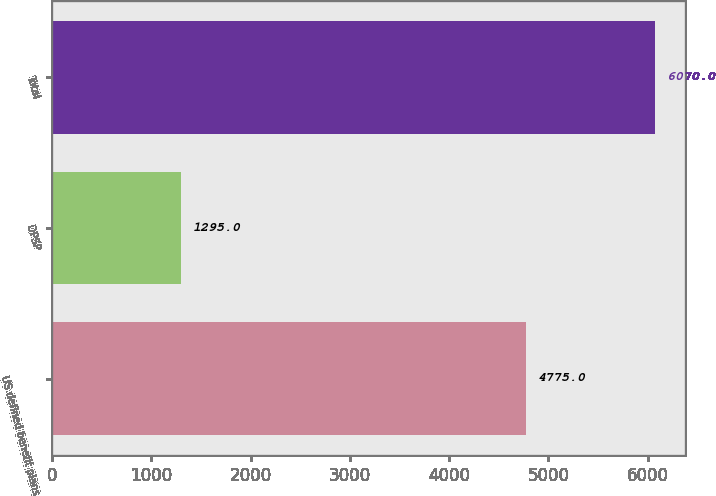<chart> <loc_0><loc_0><loc_500><loc_500><bar_chart><fcel>US defined benefit plans<fcel>DPSP<fcel>Total<nl><fcel>4775<fcel>1295<fcel>6070<nl></chart> 